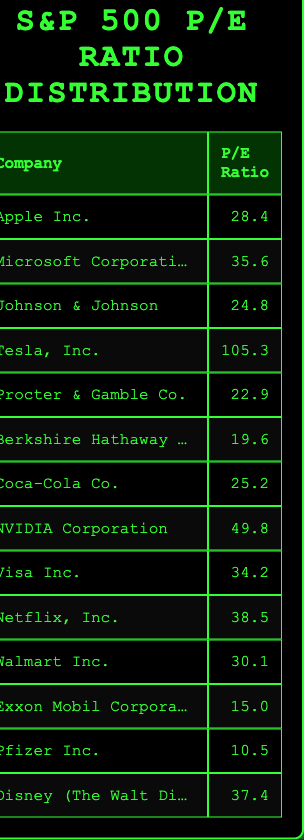What is the highest P/E ratio among the companies listed? The company with the highest P/E ratio is Tesla, Inc., which has a P/E ratio of 105.3. This value can be directly identified by scanning the P/E Ratio column in the table.
Answer: 105.3 Which company has the lowest P/E ratio? The company with the lowest P/E ratio is Pfizer Inc. with a P/E ratio of 10.5. This can be determined by comparing all the P/E ratios listed in the table.
Answer: 10.5 What is the average P/E ratio of the companies in the table? To calculate the average, first sum all the P/E ratios: 28.4 + 35.6 + 24.8 + 105.3 + 22.9 + 19.6 + 25.2 + 49.8 + 34.2 + 38.5 + 30.1 + 15.0 + 10.5 + 37.4 =  438.9. Then divide by the number of companies, which is 14: 438.9 / 14 = 31.35.
Answer: 31.35 Is there a company with a P/E ratio greater than 50? Yes, NVIDIA Corporation has a P/E ratio of 49.8, and Tesla, Inc. has a P/E ratio of 105.3. Both of these figures indicate that there are companies with P/E ratios greater than 50.
Answer: Yes How many companies have P/E ratios above the average value calculated? The average P/E ratio was calculated as 31.35. The companies with P/E ratios above this value are Microsoft Corporation (35.6), Tesla, Inc. (105.3), NVIDIA Corporation (49.8), Visa Inc. (34.2), Netflix, Inc. (38.5), and Disney (The Walt Disney Company) (37.4). There are a total of 6 companies.
Answer: 6 